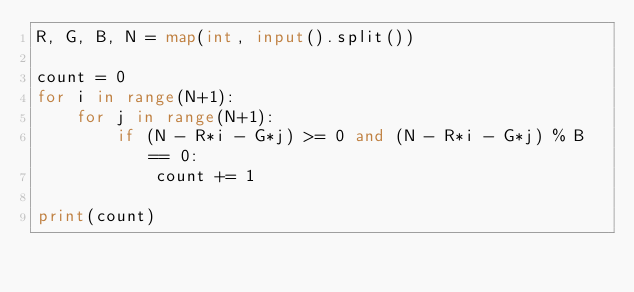<code> <loc_0><loc_0><loc_500><loc_500><_Python_>R, G, B, N = map(int, input().split())

count = 0
for i in range(N+1):
    for j in range(N+1):
        if (N - R*i - G*j) >= 0 and (N - R*i - G*j) % B == 0:
            count += 1

print(count)
</code> 